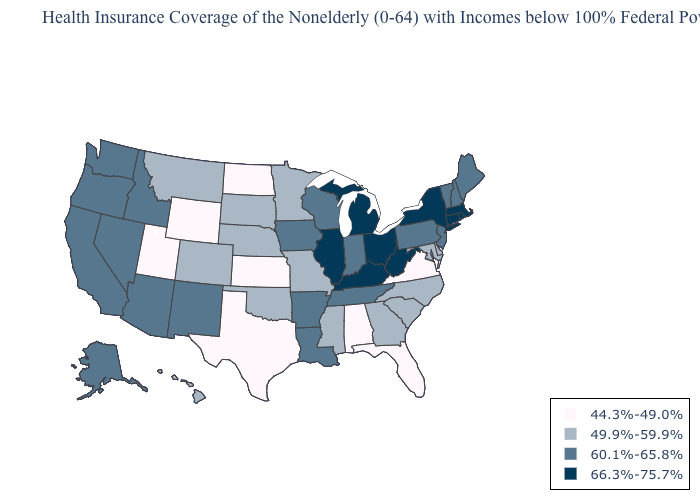What is the value of Iowa?
Quick response, please. 60.1%-65.8%. What is the value of Wisconsin?
Be succinct. 60.1%-65.8%. Among the states that border Idaho , which have the highest value?
Answer briefly. Nevada, Oregon, Washington. What is the highest value in states that border Montana?
Be succinct. 60.1%-65.8%. Name the states that have a value in the range 44.3%-49.0%?
Answer briefly. Alabama, Florida, Kansas, North Dakota, Texas, Utah, Virginia, Wyoming. Does Rhode Island have a higher value than New York?
Give a very brief answer. No. What is the value of Idaho?
Keep it brief. 60.1%-65.8%. What is the highest value in the South ?
Concise answer only. 66.3%-75.7%. How many symbols are there in the legend?
Quick response, please. 4. Name the states that have a value in the range 49.9%-59.9%?
Short answer required. Colorado, Delaware, Georgia, Hawaii, Maryland, Minnesota, Mississippi, Missouri, Montana, Nebraska, North Carolina, Oklahoma, South Carolina, South Dakota. What is the value of Rhode Island?
Write a very short answer. 66.3%-75.7%. Does Kansas have the highest value in the MidWest?
Write a very short answer. No. What is the lowest value in the South?
Short answer required. 44.3%-49.0%. What is the lowest value in the USA?
Keep it brief. 44.3%-49.0%. Does Iowa have the highest value in the MidWest?
Be succinct. No. 